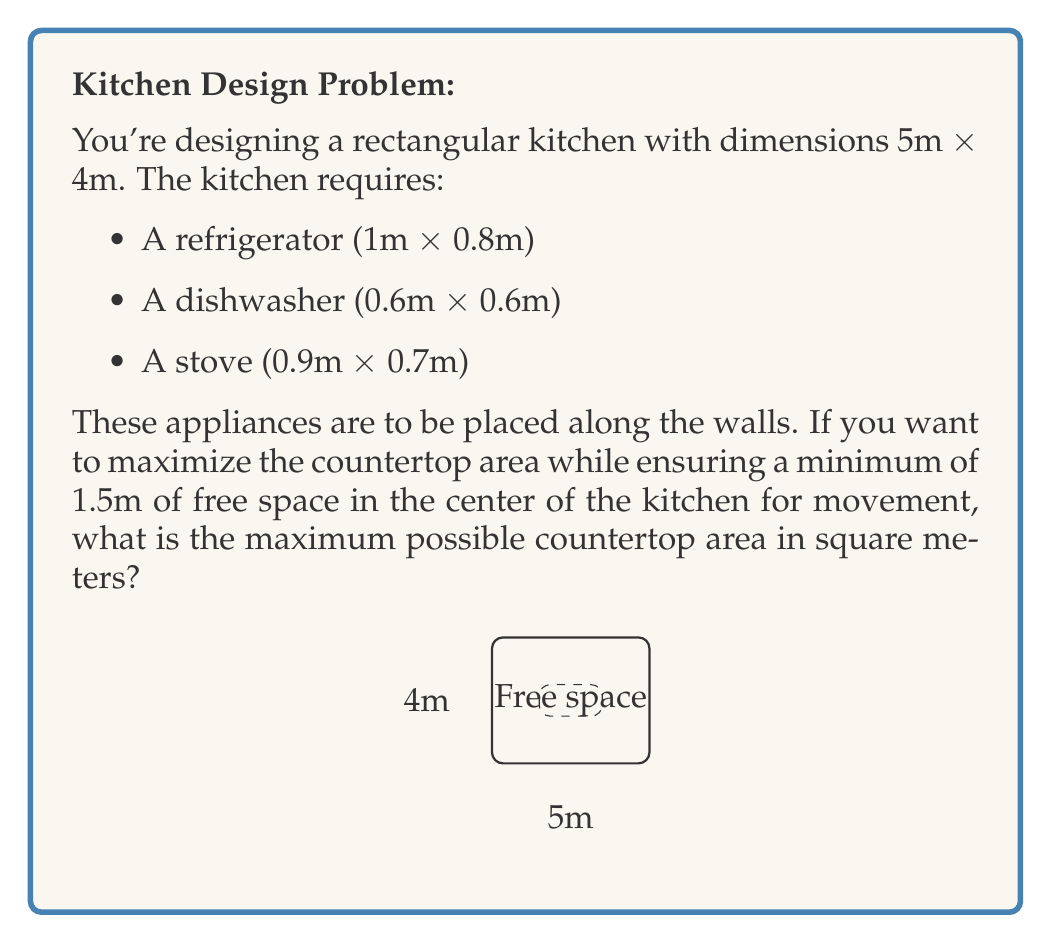Provide a solution to this math problem. Let's approach this step-by-step:

1) First, calculate the total area of the kitchen:
   $A_{total} = 5m \times 4m = 20m^2$

2) Calculate the area of the appliances:
   $A_{appliances} = (1 \times 0.8) + (0.6 \times 0.6) + (0.9 \times 0.7) = 1.59m^2$

3) Calculate the minimum free space area:
   $A_{free} = 1.5m \times 1.5m = 2.25m^2$

4) The maximum countertop area will be the remaining space:
   $A_{countertop} = A_{total} - A_{appliances} - A_{free}$

5) Substitute the values:
   $A_{countertop} = 20m^2 - 1.59m^2 - 2.25m^2 = 16.16m^2$

Therefore, the maximum possible countertop area is 16.16 square meters.
Answer: $16.16m^2$ 